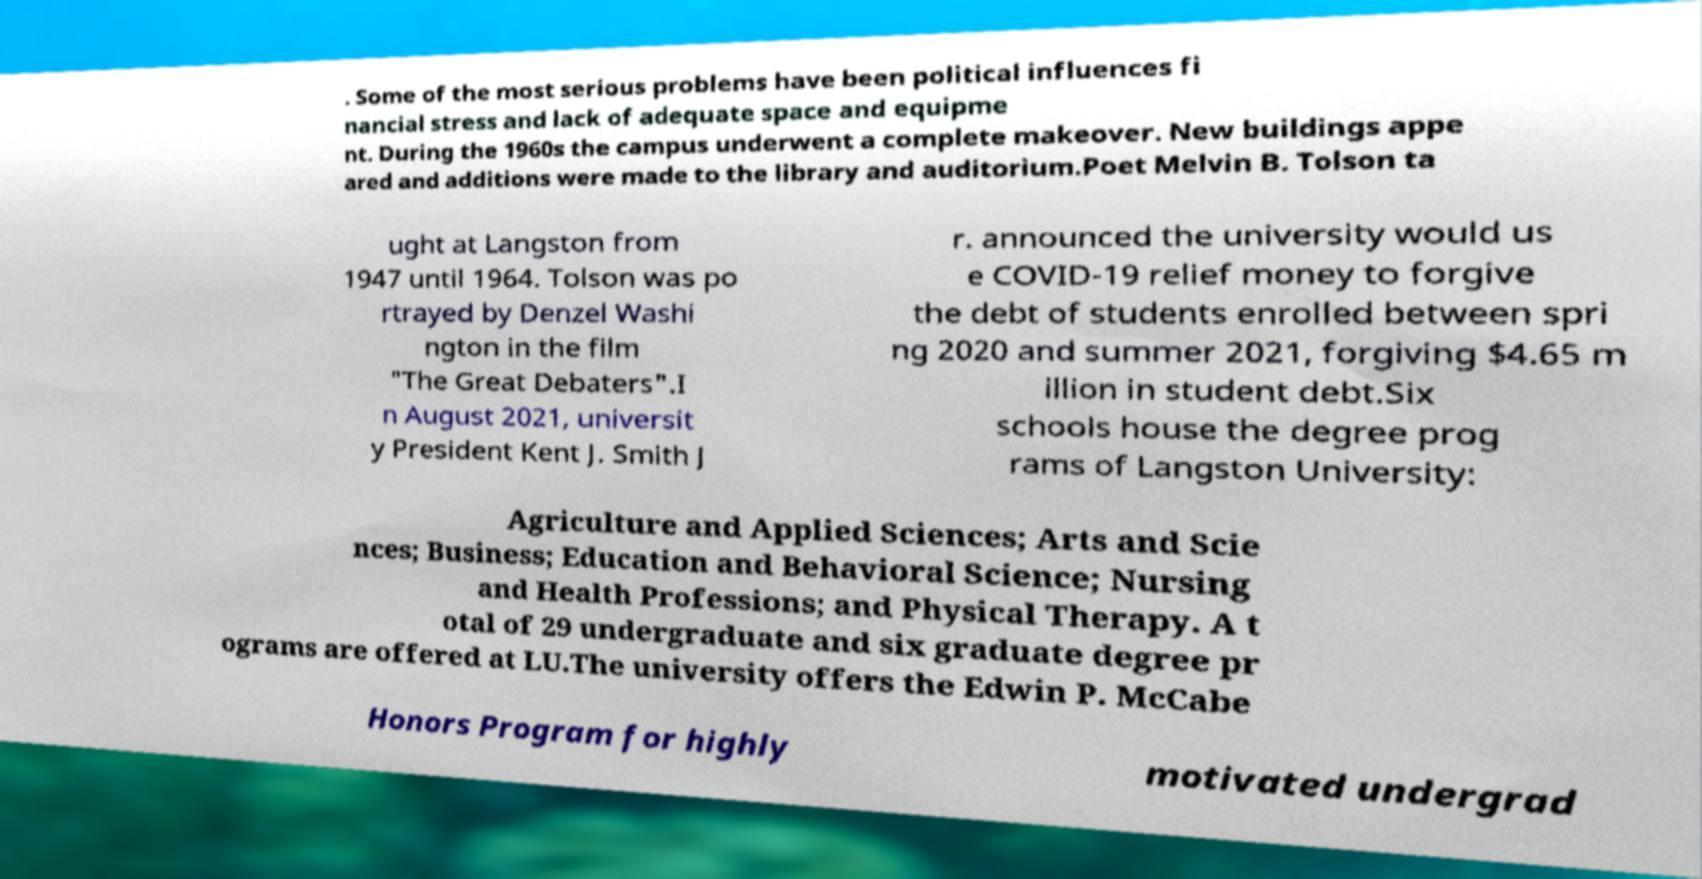Please read and relay the text visible in this image. What does it say? . Some of the most serious problems have been political influences fi nancial stress and lack of adequate space and equipme nt. During the 1960s the campus underwent a complete makeover. New buildings appe ared and additions were made to the library and auditorium.Poet Melvin B. Tolson ta ught at Langston from 1947 until 1964. Tolson was po rtrayed by Denzel Washi ngton in the film "The Great Debaters".I n August 2021, universit y President Kent J. Smith J r. announced the university would us e COVID-19 relief money to forgive the debt of students enrolled between spri ng 2020 and summer 2021, forgiving $4.65 m illion in student debt.Six schools house the degree prog rams of Langston University: Agriculture and Applied Sciences; Arts and Scie nces; Business; Education and Behavioral Science; Nursing and Health Professions; and Physical Therapy. A t otal of 29 undergraduate and six graduate degree pr ograms are offered at LU.The university offers the Edwin P. McCabe Honors Program for highly motivated undergrad 